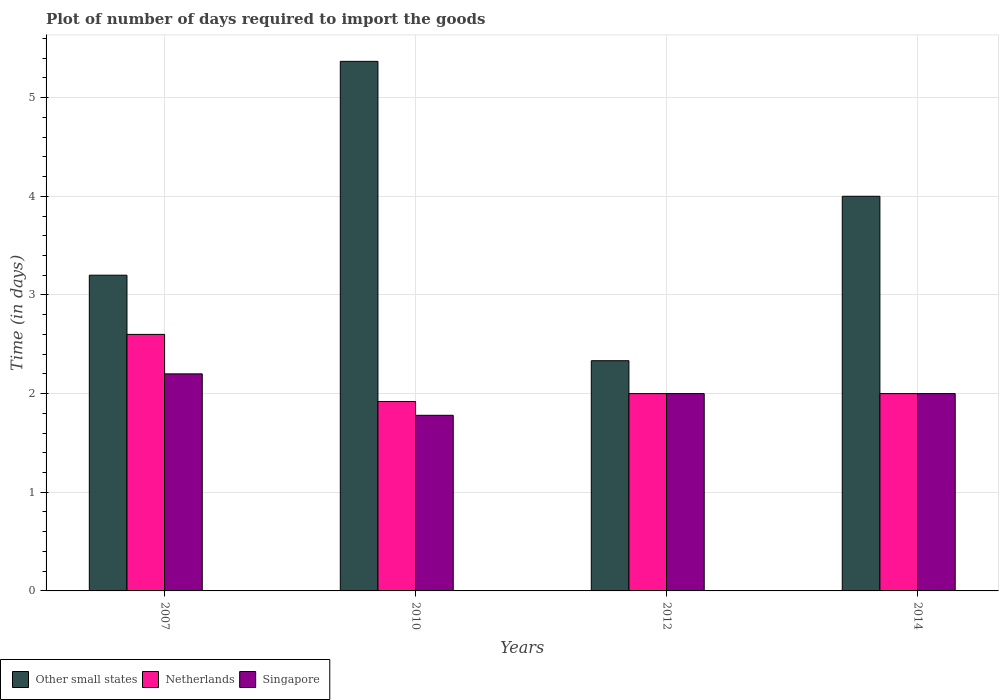How many groups of bars are there?
Keep it short and to the point. 4. Are the number of bars per tick equal to the number of legend labels?
Provide a short and direct response. Yes. What is the time required to import goods in Netherlands in 2010?
Ensure brevity in your answer.  1.92. Across all years, what is the maximum time required to import goods in Other small states?
Your response must be concise. 5.37. Across all years, what is the minimum time required to import goods in Singapore?
Your answer should be compact. 1.78. In which year was the time required to import goods in Singapore maximum?
Provide a short and direct response. 2007. What is the total time required to import goods in Other small states in the graph?
Offer a very short reply. 14.9. What is the difference between the time required to import goods in Other small states in 2010 and that in 2014?
Make the answer very short. 1.37. What is the average time required to import goods in Singapore per year?
Offer a very short reply. 2. In how many years, is the time required to import goods in Netherlands greater than 5.2 days?
Provide a succinct answer. 0. What is the ratio of the time required to import goods in Netherlands in 2010 to that in 2012?
Offer a terse response. 0.96. Is the difference between the time required to import goods in Netherlands in 2007 and 2014 greater than the difference between the time required to import goods in Other small states in 2007 and 2014?
Keep it short and to the point. Yes. What is the difference between the highest and the second highest time required to import goods in Singapore?
Offer a very short reply. 0.2. What is the difference between the highest and the lowest time required to import goods in Singapore?
Provide a short and direct response. 0.42. In how many years, is the time required to import goods in Netherlands greater than the average time required to import goods in Netherlands taken over all years?
Give a very brief answer. 1. What does the 1st bar from the left in 2010 represents?
Ensure brevity in your answer.  Other small states. What does the 2nd bar from the right in 2010 represents?
Provide a short and direct response. Netherlands. How many years are there in the graph?
Make the answer very short. 4. What is the difference between two consecutive major ticks on the Y-axis?
Provide a short and direct response. 1. Are the values on the major ticks of Y-axis written in scientific E-notation?
Your answer should be compact. No. Does the graph contain any zero values?
Make the answer very short. No. What is the title of the graph?
Your response must be concise. Plot of number of days required to import the goods. Does "Central Europe" appear as one of the legend labels in the graph?
Your response must be concise. No. What is the label or title of the Y-axis?
Ensure brevity in your answer.  Time (in days). What is the Time (in days) of Other small states in 2007?
Your response must be concise. 3.2. What is the Time (in days) in Singapore in 2007?
Your answer should be very brief. 2.2. What is the Time (in days) in Other small states in 2010?
Make the answer very short. 5.37. What is the Time (in days) of Netherlands in 2010?
Ensure brevity in your answer.  1.92. What is the Time (in days) in Singapore in 2010?
Ensure brevity in your answer.  1.78. What is the Time (in days) in Other small states in 2012?
Offer a terse response. 2.33. What is the Time (in days) in Netherlands in 2012?
Give a very brief answer. 2. What is the Time (in days) in Singapore in 2012?
Provide a short and direct response. 2. Across all years, what is the maximum Time (in days) in Other small states?
Offer a terse response. 5.37. Across all years, what is the maximum Time (in days) in Netherlands?
Offer a terse response. 2.6. Across all years, what is the minimum Time (in days) of Other small states?
Make the answer very short. 2.33. Across all years, what is the minimum Time (in days) of Netherlands?
Ensure brevity in your answer.  1.92. Across all years, what is the minimum Time (in days) in Singapore?
Your response must be concise. 1.78. What is the total Time (in days) in Other small states in the graph?
Ensure brevity in your answer.  14.9. What is the total Time (in days) in Netherlands in the graph?
Your response must be concise. 8.52. What is the total Time (in days) of Singapore in the graph?
Give a very brief answer. 7.98. What is the difference between the Time (in days) of Other small states in 2007 and that in 2010?
Give a very brief answer. -2.17. What is the difference between the Time (in days) in Netherlands in 2007 and that in 2010?
Your answer should be compact. 0.68. What is the difference between the Time (in days) of Singapore in 2007 and that in 2010?
Keep it short and to the point. 0.42. What is the difference between the Time (in days) of Other small states in 2007 and that in 2012?
Offer a terse response. 0.87. What is the difference between the Time (in days) of Other small states in 2007 and that in 2014?
Provide a short and direct response. -0.8. What is the difference between the Time (in days) in Netherlands in 2007 and that in 2014?
Make the answer very short. 0.6. What is the difference between the Time (in days) in Other small states in 2010 and that in 2012?
Ensure brevity in your answer.  3.03. What is the difference between the Time (in days) of Netherlands in 2010 and that in 2012?
Make the answer very short. -0.08. What is the difference between the Time (in days) in Singapore in 2010 and that in 2012?
Give a very brief answer. -0.22. What is the difference between the Time (in days) of Other small states in 2010 and that in 2014?
Offer a very short reply. 1.37. What is the difference between the Time (in days) of Netherlands in 2010 and that in 2014?
Provide a short and direct response. -0.08. What is the difference between the Time (in days) in Singapore in 2010 and that in 2014?
Keep it short and to the point. -0.22. What is the difference between the Time (in days) of Other small states in 2012 and that in 2014?
Your answer should be compact. -1.67. What is the difference between the Time (in days) of Netherlands in 2012 and that in 2014?
Provide a succinct answer. 0. What is the difference between the Time (in days) of Singapore in 2012 and that in 2014?
Offer a terse response. 0. What is the difference between the Time (in days) of Other small states in 2007 and the Time (in days) of Netherlands in 2010?
Offer a terse response. 1.28. What is the difference between the Time (in days) in Other small states in 2007 and the Time (in days) in Singapore in 2010?
Offer a very short reply. 1.42. What is the difference between the Time (in days) in Netherlands in 2007 and the Time (in days) in Singapore in 2010?
Offer a very short reply. 0.82. What is the difference between the Time (in days) of Other small states in 2007 and the Time (in days) of Singapore in 2012?
Make the answer very short. 1.2. What is the difference between the Time (in days) in Other small states in 2007 and the Time (in days) in Netherlands in 2014?
Provide a succinct answer. 1.2. What is the difference between the Time (in days) of Netherlands in 2007 and the Time (in days) of Singapore in 2014?
Provide a succinct answer. 0.6. What is the difference between the Time (in days) of Other small states in 2010 and the Time (in days) of Netherlands in 2012?
Provide a short and direct response. 3.37. What is the difference between the Time (in days) of Other small states in 2010 and the Time (in days) of Singapore in 2012?
Make the answer very short. 3.37. What is the difference between the Time (in days) of Netherlands in 2010 and the Time (in days) of Singapore in 2012?
Your answer should be very brief. -0.08. What is the difference between the Time (in days) of Other small states in 2010 and the Time (in days) of Netherlands in 2014?
Provide a succinct answer. 3.37. What is the difference between the Time (in days) of Other small states in 2010 and the Time (in days) of Singapore in 2014?
Provide a succinct answer. 3.37. What is the difference between the Time (in days) in Netherlands in 2010 and the Time (in days) in Singapore in 2014?
Your response must be concise. -0.08. What is the difference between the Time (in days) in Other small states in 2012 and the Time (in days) in Singapore in 2014?
Your response must be concise. 0.33. What is the average Time (in days) of Other small states per year?
Ensure brevity in your answer.  3.73. What is the average Time (in days) in Netherlands per year?
Keep it short and to the point. 2.13. What is the average Time (in days) in Singapore per year?
Your answer should be compact. 2. In the year 2007, what is the difference between the Time (in days) of Netherlands and Time (in days) of Singapore?
Ensure brevity in your answer.  0.4. In the year 2010, what is the difference between the Time (in days) of Other small states and Time (in days) of Netherlands?
Offer a very short reply. 3.45. In the year 2010, what is the difference between the Time (in days) in Other small states and Time (in days) in Singapore?
Offer a terse response. 3.59. In the year 2010, what is the difference between the Time (in days) in Netherlands and Time (in days) in Singapore?
Ensure brevity in your answer.  0.14. What is the ratio of the Time (in days) of Other small states in 2007 to that in 2010?
Give a very brief answer. 0.6. What is the ratio of the Time (in days) of Netherlands in 2007 to that in 2010?
Offer a very short reply. 1.35. What is the ratio of the Time (in days) of Singapore in 2007 to that in 2010?
Your response must be concise. 1.24. What is the ratio of the Time (in days) in Other small states in 2007 to that in 2012?
Offer a very short reply. 1.37. What is the ratio of the Time (in days) in Singapore in 2007 to that in 2012?
Keep it short and to the point. 1.1. What is the ratio of the Time (in days) of Other small states in 2007 to that in 2014?
Your answer should be very brief. 0.8. What is the ratio of the Time (in days) in Singapore in 2007 to that in 2014?
Offer a very short reply. 1.1. What is the ratio of the Time (in days) of Other small states in 2010 to that in 2012?
Your answer should be very brief. 2.3. What is the ratio of the Time (in days) of Singapore in 2010 to that in 2012?
Provide a succinct answer. 0.89. What is the ratio of the Time (in days) in Other small states in 2010 to that in 2014?
Keep it short and to the point. 1.34. What is the ratio of the Time (in days) in Singapore in 2010 to that in 2014?
Provide a short and direct response. 0.89. What is the ratio of the Time (in days) in Other small states in 2012 to that in 2014?
Provide a short and direct response. 0.58. What is the difference between the highest and the second highest Time (in days) of Other small states?
Offer a terse response. 1.37. What is the difference between the highest and the second highest Time (in days) in Netherlands?
Ensure brevity in your answer.  0.6. What is the difference between the highest and the lowest Time (in days) of Other small states?
Your response must be concise. 3.03. What is the difference between the highest and the lowest Time (in days) of Netherlands?
Provide a short and direct response. 0.68. What is the difference between the highest and the lowest Time (in days) of Singapore?
Your answer should be very brief. 0.42. 